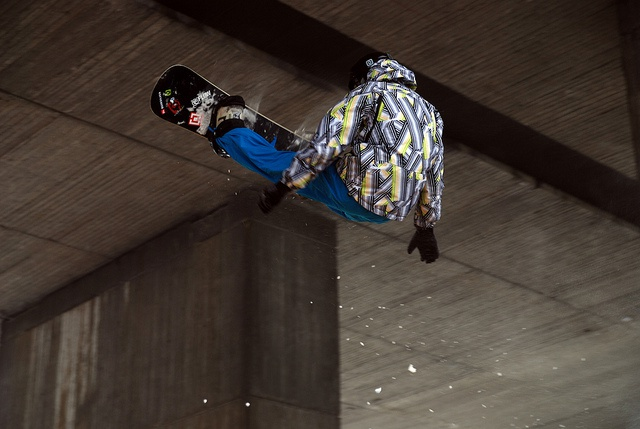Describe the objects in this image and their specific colors. I can see people in black, gray, darkgray, and navy tones, snowboard in black, gray, darkgray, and maroon tones, and skateboard in black, gray, darkgray, and maroon tones in this image. 